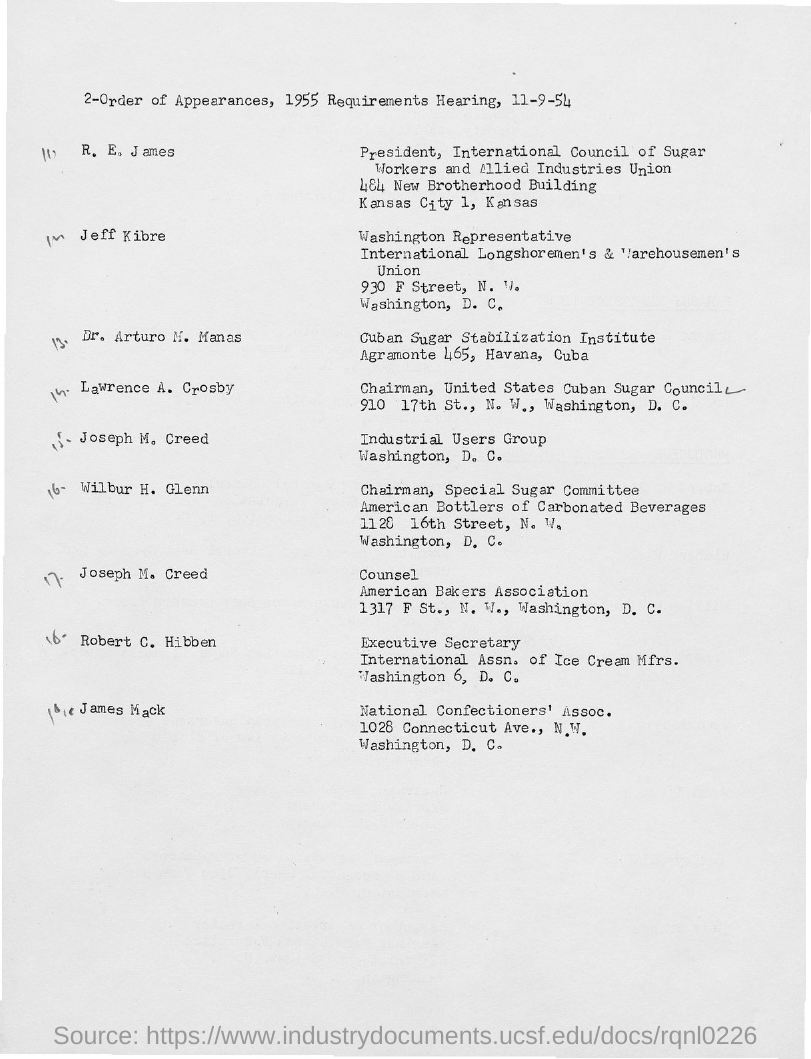Who is the counsel of American Bakers Association?
Offer a very short reply. Joseph M. Creed. Who is the Executive Secretary of International Assn. of Ice Cream Mfrs.?
Offer a terse response. Robert C. Hibben. Who is the chairman of united states cuban sugar council?
Offer a terse response. Lawrence A. Crosby. 